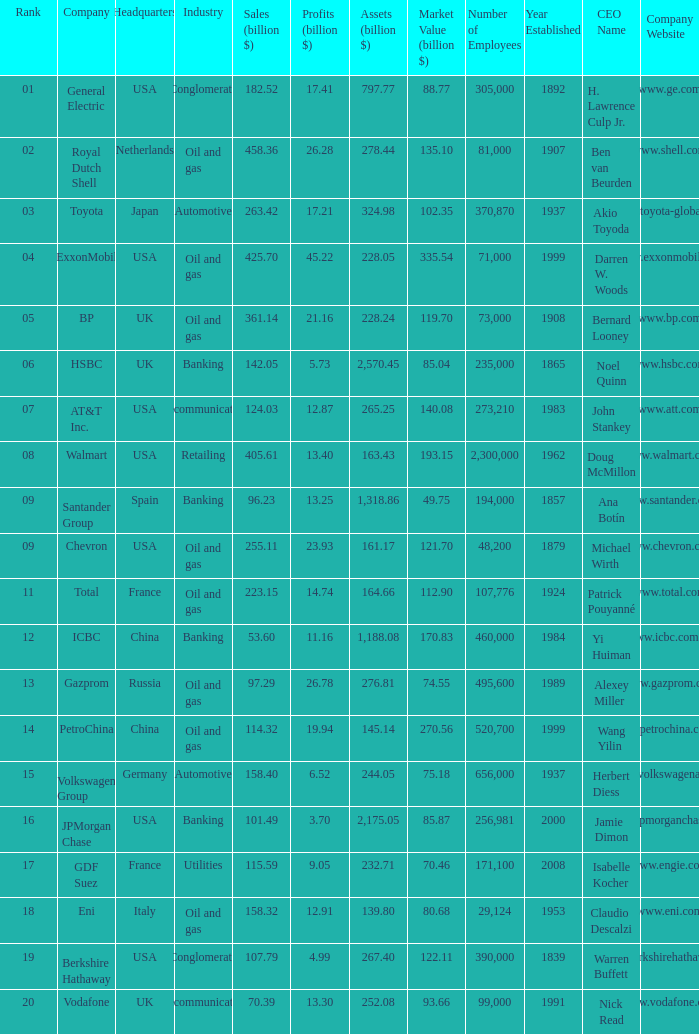How many Assets (billion $) has an Industry of oil and gas, and a Rank of 9, and a Market Value (billion $) larger than 121.7? None. 